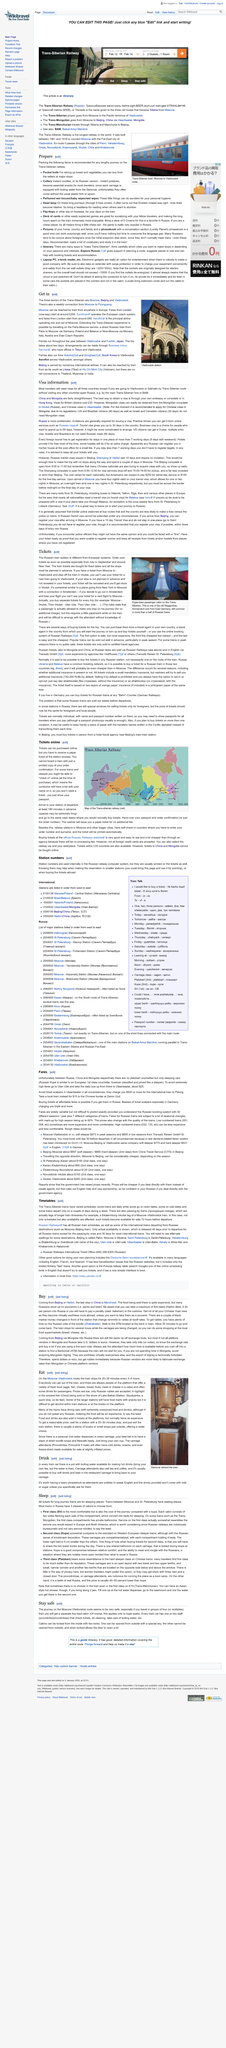Outline some significant characteristics in this image. This page is editable. The full journey takes approximately 6 days 15 hours and 20 minutes. The most effective method of obtaining a visa to visit China and Mongolia is through the embassy or consulate, or through the visa application center in Hong Kong. Manzhouli is the last stop in China from Beijing. The weekly connections from Moscow to Pyongyang are from where? 